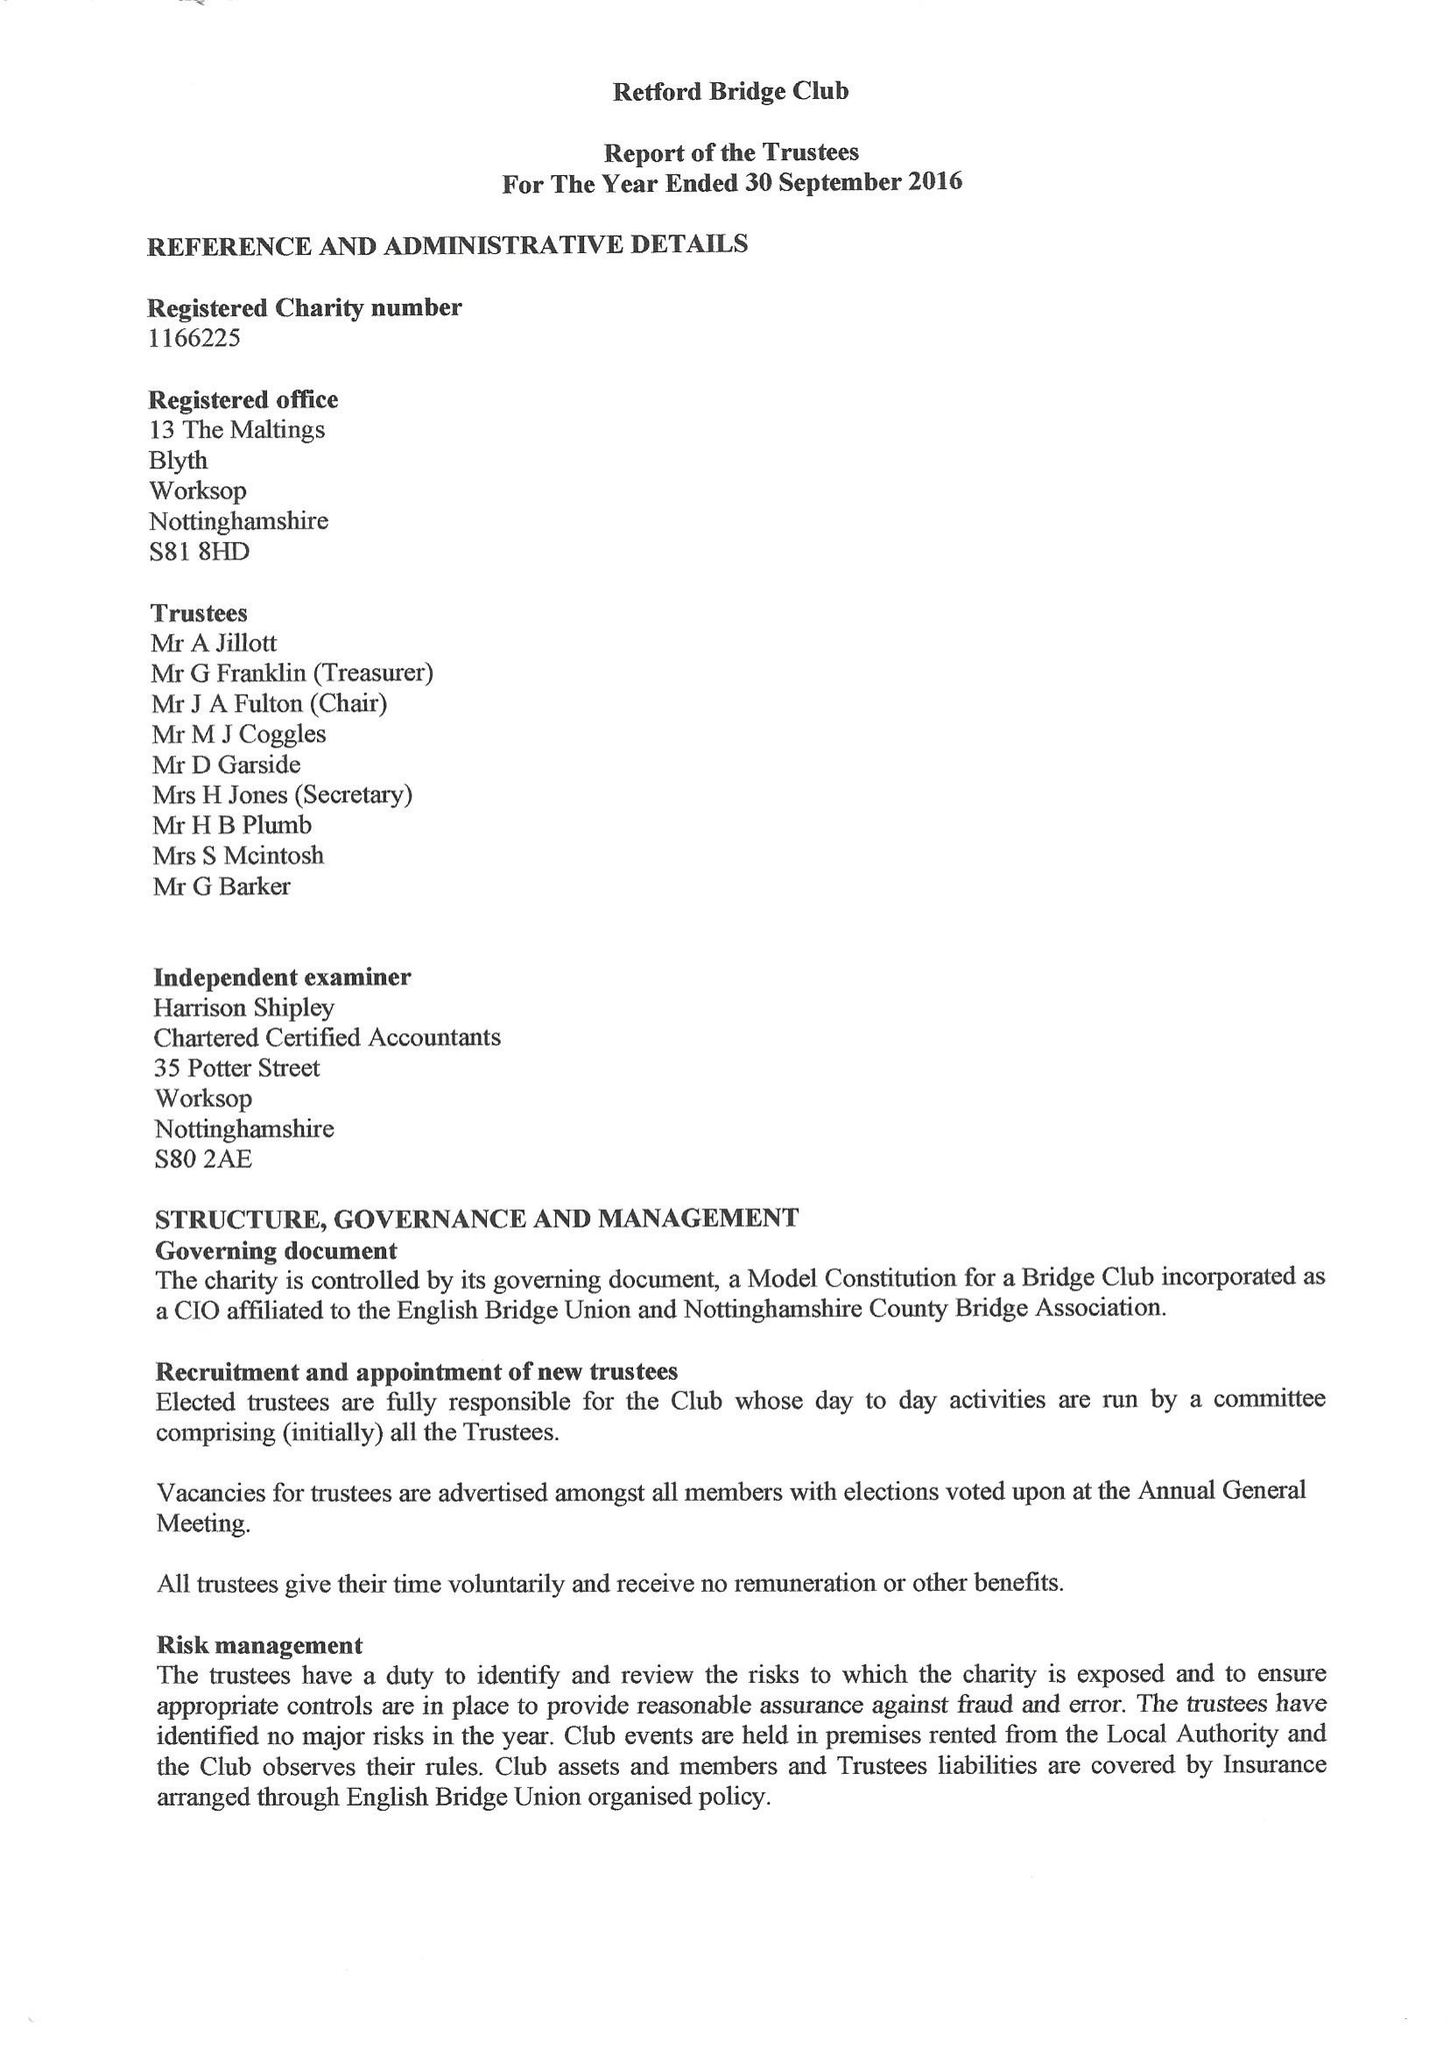What is the value for the address__postcode?
Answer the question using a single word or phrase. S81 8HD 